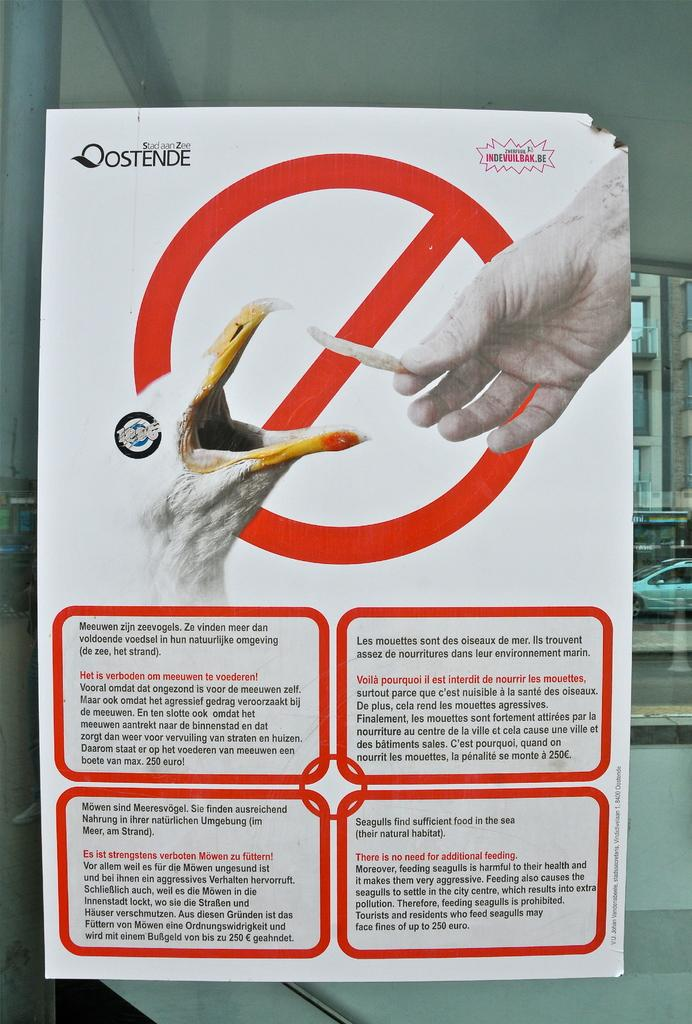What is depicted on the paper in the image? The paper contains an image of a bird and a person's hand. What else can be found on the paper? There is text on the paper. What is located on the right side of the image? There is a vehicle on the right side of the image. How many stamps are on the paper in the image? There is no mention of stamps on the paper in the image. What type of robin is perched on the person's hand in the image? There is no robin present in the image; the paper only contains an image of a bird, not specifically a robin. 